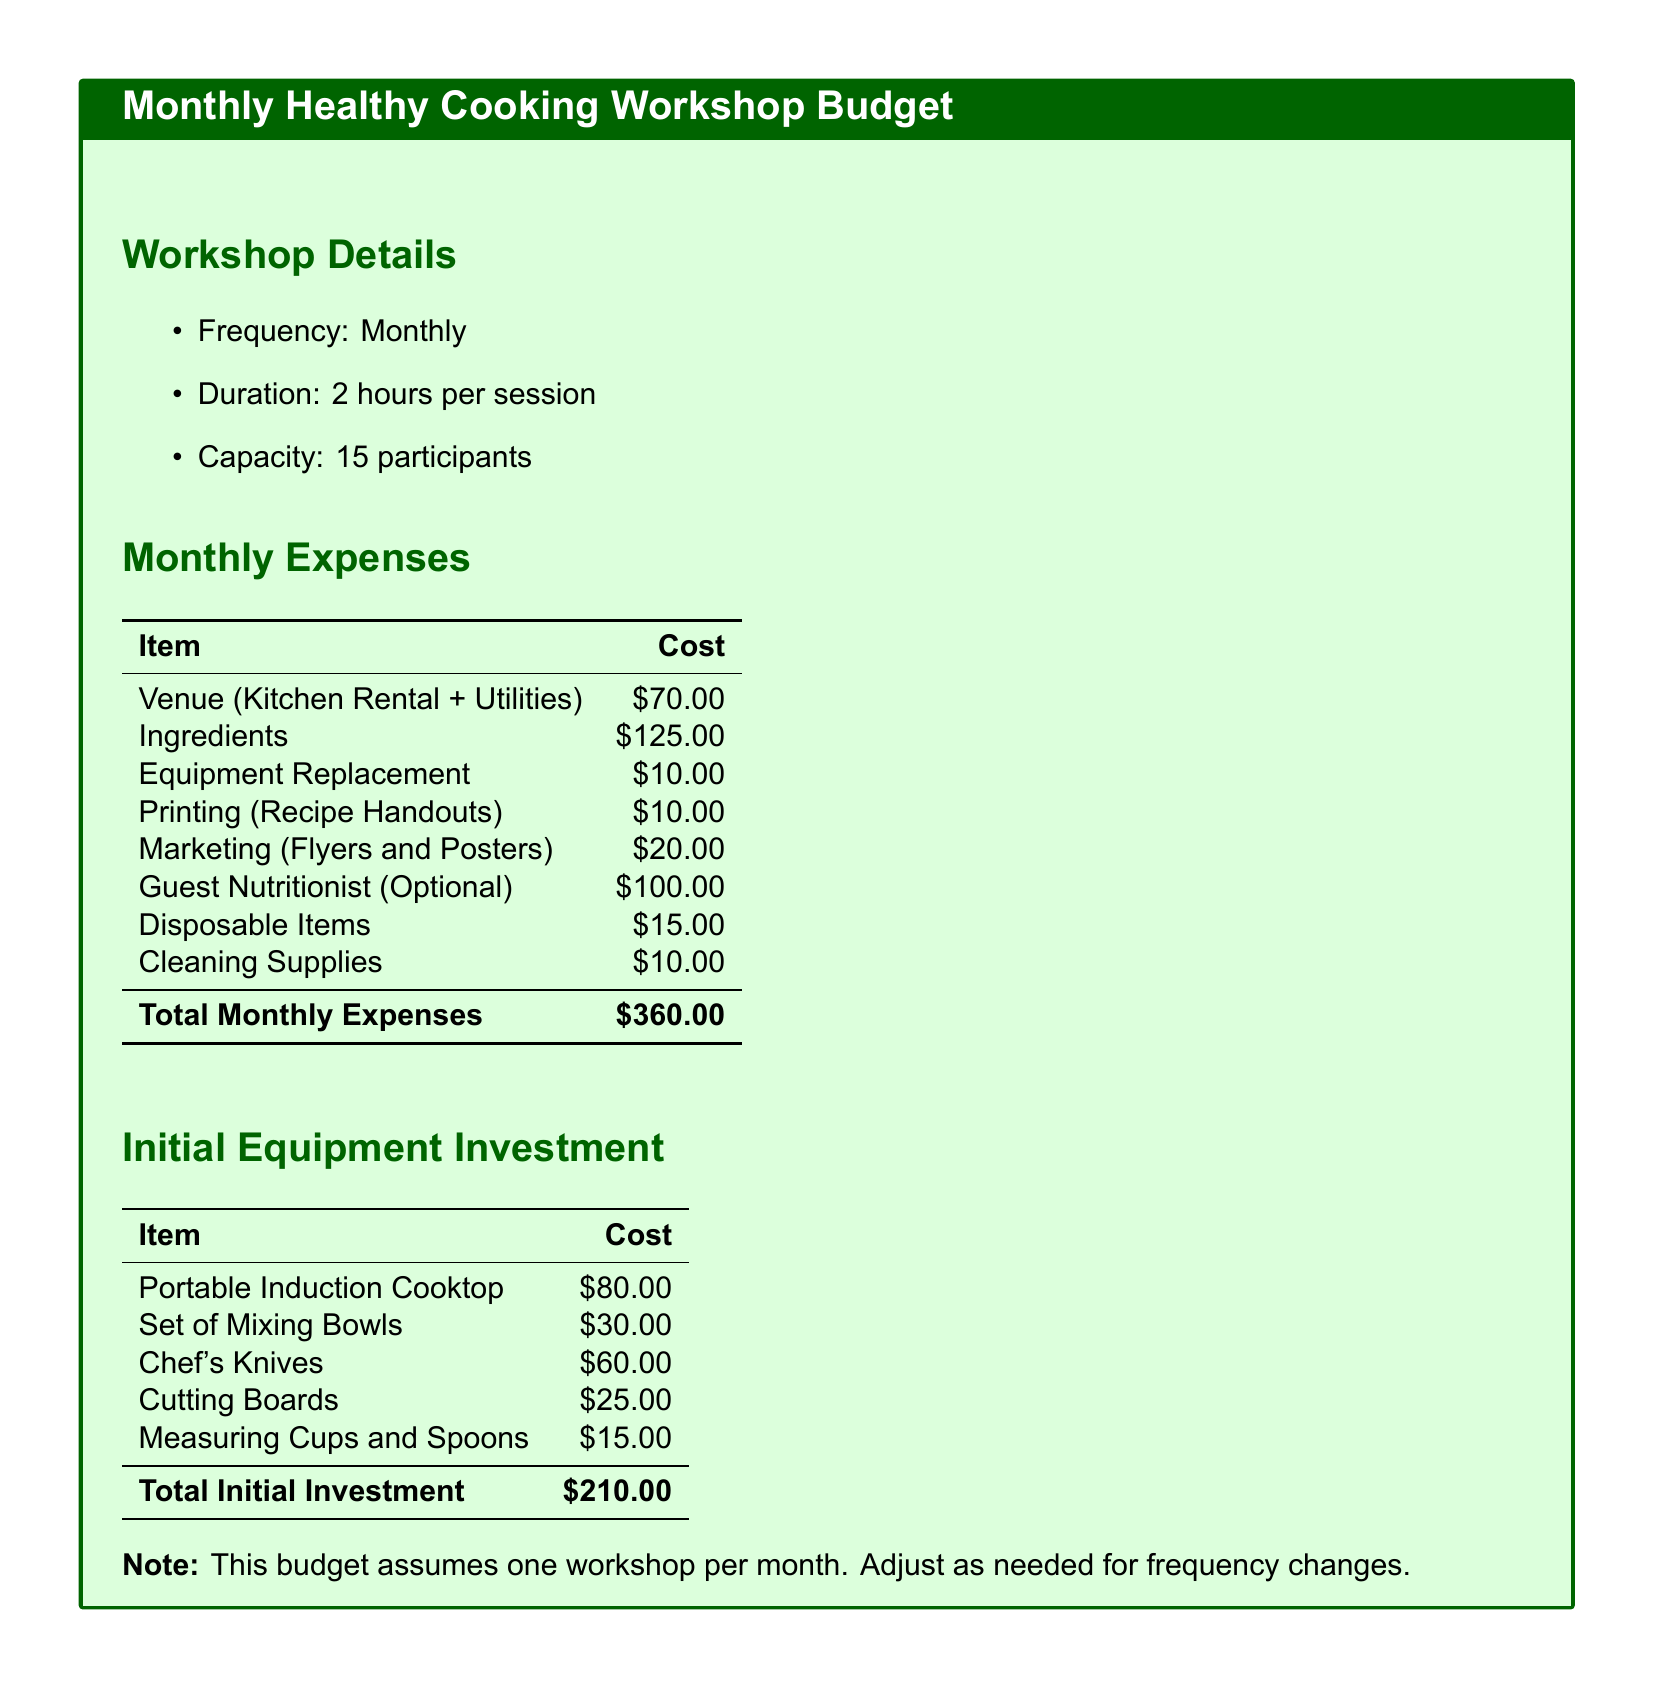What is the frequency of the workshops? The document states that the workshops are held on a monthly basis.
Answer: Monthly What is the total cost for ingredients? The budget lists $125.00 as the cost for ingredients in the monthly expenses section.
Answer: $125.00 How many participants can the workshops accommodate? The document specifies that the capacity for each workshop is 15 participants.
Answer: 15 What is the cost of the venue? The venue cost listed in the document is $70.00 for kitchen rental and utilities.
Answer: $70.00 What is the total monthly expense of hosting these workshops? The total monthly expenses combine all listed costs, resulting in $360.00.
Answer: $360.00 What is the initial equipment investment total? The section on initial equipment investment sums up to $210.00 as shown in the document.
Answer: $210.00 How much does it cost to hire a guest nutritionist? The optional cost for hiring a guest nutritionist is stated as $100.00.
Answer: $100.00 What item costs $15.00? The document indicates that disposable items have a cost of $15.00.
Answer: $15.00 How many hours does each workshop last? The duration of each session is specified as 2 hours in the workshop details.
Answer: 2 hours 